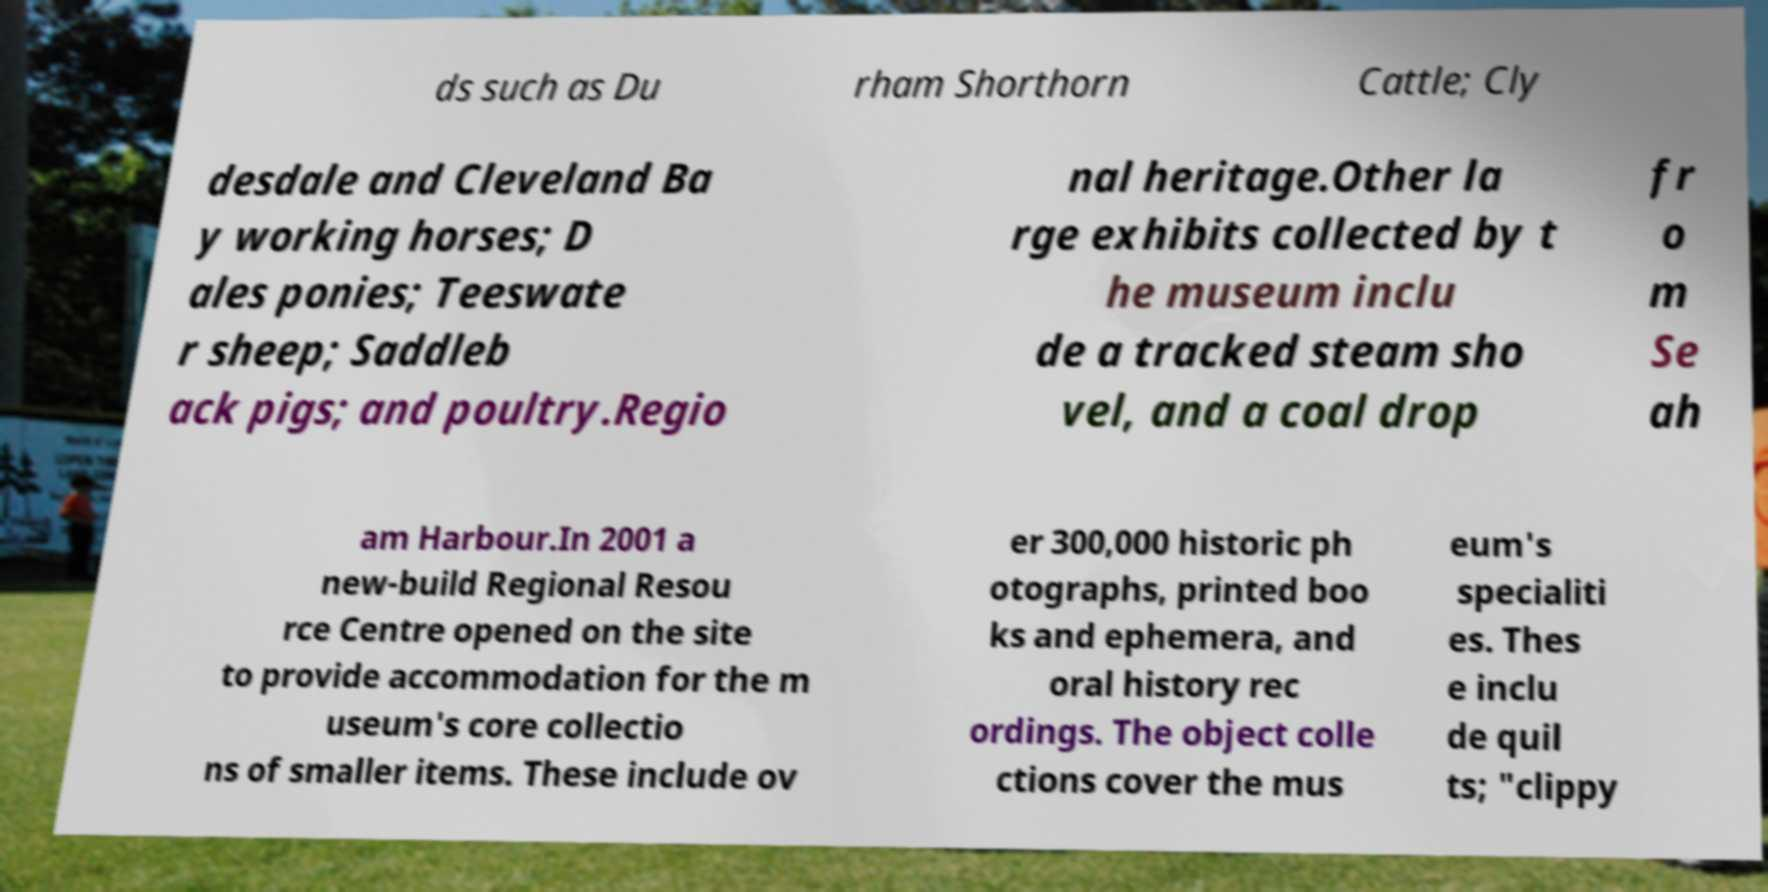Could you assist in decoding the text presented in this image and type it out clearly? ds such as Du rham Shorthorn Cattle; Cly desdale and Cleveland Ba y working horses; D ales ponies; Teeswate r sheep; Saddleb ack pigs; and poultry.Regio nal heritage.Other la rge exhibits collected by t he museum inclu de a tracked steam sho vel, and a coal drop fr o m Se ah am Harbour.In 2001 a new-build Regional Resou rce Centre opened on the site to provide accommodation for the m useum's core collectio ns of smaller items. These include ov er 300,000 historic ph otographs, printed boo ks and ephemera, and oral history rec ordings. The object colle ctions cover the mus eum's specialiti es. Thes e inclu de quil ts; "clippy 